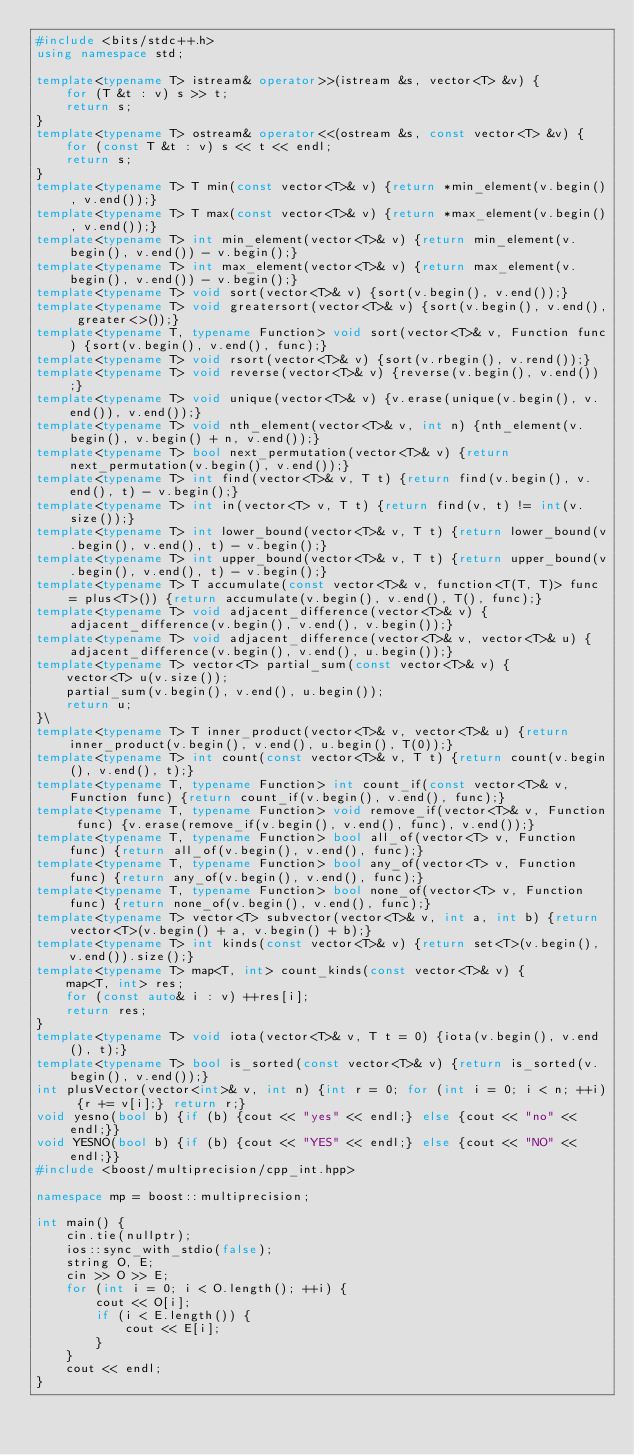<code> <loc_0><loc_0><loc_500><loc_500><_C++_>#include <bits/stdc++.h>
using namespace std;

template<typename T> istream& operator>>(istream &s, vector<T> &v) {
    for (T &t : v) s >> t;
    return s;
}
template<typename T> ostream& operator<<(ostream &s, const vector<T> &v) {
    for (const T &t : v) s << t << endl;
    return s;
}
template<typename T> T min(const vector<T>& v) {return *min_element(v.begin(), v.end());}
template<typename T> T max(const vector<T>& v) {return *max_element(v.begin(), v.end());}
template<typename T> int min_element(vector<T>& v) {return min_element(v.begin(), v.end()) - v.begin();}
template<typename T> int max_element(vector<T>& v) {return max_element(v.begin(), v.end()) - v.begin();}
template<typename T> void sort(vector<T>& v) {sort(v.begin(), v.end());}
template<typename T> void greatersort(vector<T>& v) {sort(v.begin(), v.end(), greater<>());}
template<typename T, typename Function> void sort(vector<T>& v, Function func) {sort(v.begin(), v.end(), func);}
template<typename T> void rsort(vector<T>& v) {sort(v.rbegin(), v.rend());}
template<typename T> void reverse(vector<T>& v) {reverse(v.begin(), v.end());}
template<typename T> void unique(vector<T>& v) {v.erase(unique(v.begin(), v.end()), v.end());}
template<typename T> void nth_element(vector<T>& v, int n) {nth_element(v.begin(), v.begin() + n, v.end());}
template<typename T> bool next_permutation(vector<T>& v) {return next_permutation(v.begin(), v.end());}
template<typename T> int find(vector<T>& v, T t) {return find(v.begin(), v.end(), t) - v.begin();}
template<typename T> int in(vector<T> v, T t) {return find(v, t) != int(v.size());}
template<typename T> int lower_bound(vector<T>& v, T t) {return lower_bound(v.begin(), v.end(), t) - v.begin();}
template<typename T> int upper_bound(vector<T>& v, T t) {return upper_bound(v.begin(), v.end(), t) - v.begin();}
template<typename T> T accumulate(const vector<T>& v, function<T(T, T)> func = plus<T>()) {return accumulate(v.begin(), v.end(), T(), func);}
template<typename T> void adjacent_difference(vector<T>& v) {adjacent_difference(v.begin(), v.end(), v.begin());}
template<typename T> void adjacent_difference(vector<T>& v, vector<T>& u) {adjacent_difference(v.begin(), v.end(), u.begin());}
template<typename T> vector<T> partial_sum(const vector<T>& v) {
    vector<T> u(v.size());
    partial_sum(v.begin(), v.end(), u.begin());
    return u;
}\
template<typename T> T inner_product(vector<T>& v, vector<T>& u) {return inner_product(v.begin(), v.end(), u.begin(), T(0));}
template<typename T> int count(const vector<T>& v, T t) {return count(v.begin(), v.end(), t);}
template<typename T, typename Function> int count_if(const vector<T>& v, Function func) {return count_if(v.begin(), v.end(), func);}
template<typename T, typename Function> void remove_if(vector<T>& v, Function func) {v.erase(remove_if(v.begin(), v.end(), func), v.end());}
template<typename T, typename Function> bool all_of(vector<T> v, Function func) {return all_of(v.begin(), v.end(), func);}
template<typename T, typename Function> bool any_of(vector<T> v, Function func) {return any_of(v.begin(), v.end(), func);}
template<typename T, typename Function> bool none_of(vector<T> v, Function func) {return none_of(v.begin(), v.end(), func);}
template<typename T> vector<T> subvector(vector<T>& v, int a, int b) {return vector<T>(v.begin() + a, v.begin() + b);}
template<typename T> int kinds(const vector<T>& v) {return set<T>(v.begin(), v.end()).size();}
template<typename T> map<T, int> count_kinds(const vector<T>& v) {
    map<T, int> res;
    for (const auto& i : v) ++res[i];
    return res;
}
template<typename T> void iota(vector<T>& v, T t = 0) {iota(v.begin(), v.end(), t);}
template<typename T> bool is_sorted(const vector<T>& v) {return is_sorted(v.begin(), v.end());}
int plusVector(vector<int>& v, int n) {int r = 0; for (int i = 0; i < n; ++i) {r += v[i];} return r;}
void yesno(bool b) {if (b) {cout << "yes" << endl;} else {cout << "no" << endl;}}
void YESNO(bool b) {if (b) {cout << "YES" << endl;} else {cout << "NO" << endl;}}
#include <boost/multiprecision/cpp_int.hpp>

namespace mp = boost::multiprecision;

int main() {
    cin.tie(nullptr);
    ios::sync_with_stdio(false);
    string O, E;
    cin >> O >> E;
    for (int i = 0; i < O.length(); ++i) {
        cout << O[i];
        if (i < E.length()) {
            cout << E[i];
        }
    }
    cout << endl;
}

</code> 